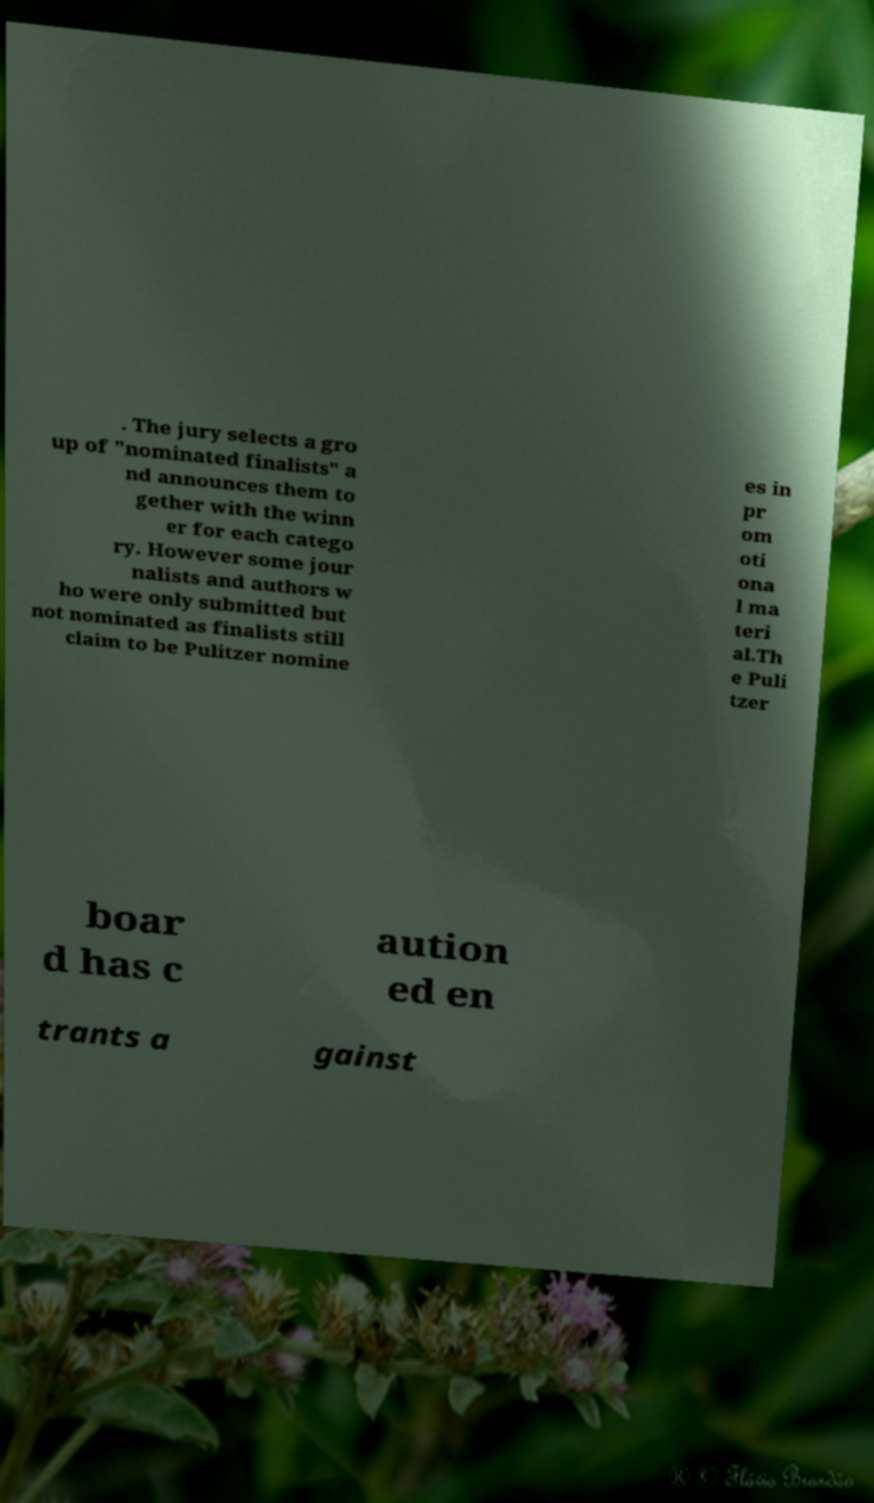Can you read and provide the text displayed in the image?This photo seems to have some interesting text. Can you extract and type it out for me? . The jury selects a gro up of "nominated finalists" a nd announces them to gether with the winn er for each catego ry. However some jour nalists and authors w ho were only submitted but not nominated as finalists still claim to be Pulitzer nomine es in pr om oti ona l ma teri al.Th e Puli tzer boar d has c aution ed en trants a gainst 